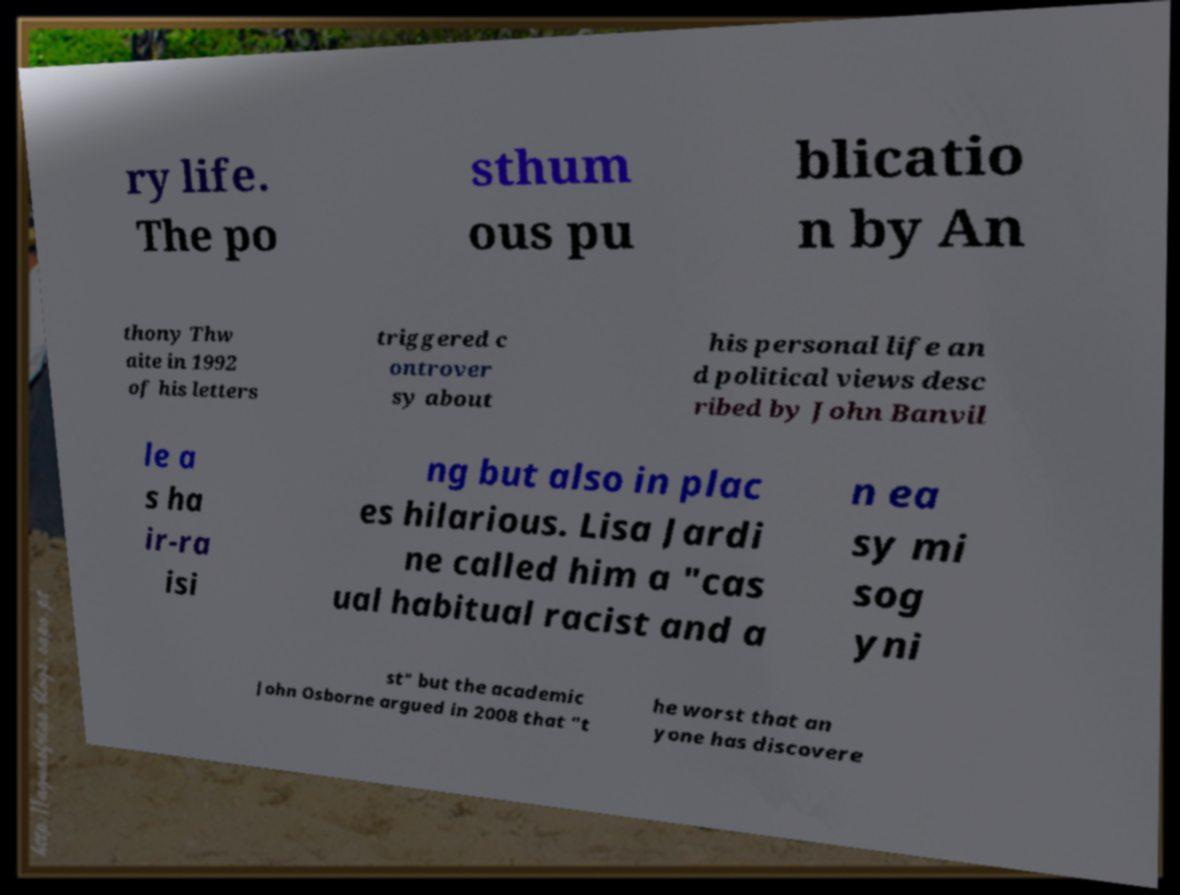I need the written content from this picture converted into text. Can you do that? ry life. The po sthum ous pu blicatio n by An thony Thw aite in 1992 of his letters triggered c ontrover sy about his personal life an d political views desc ribed by John Banvil le a s ha ir-ra isi ng but also in plac es hilarious. Lisa Jardi ne called him a "cas ual habitual racist and a n ea sy mi sog yni st" but the academic John Osborne argued in 2008 that "t he worst that an yone has discovere 